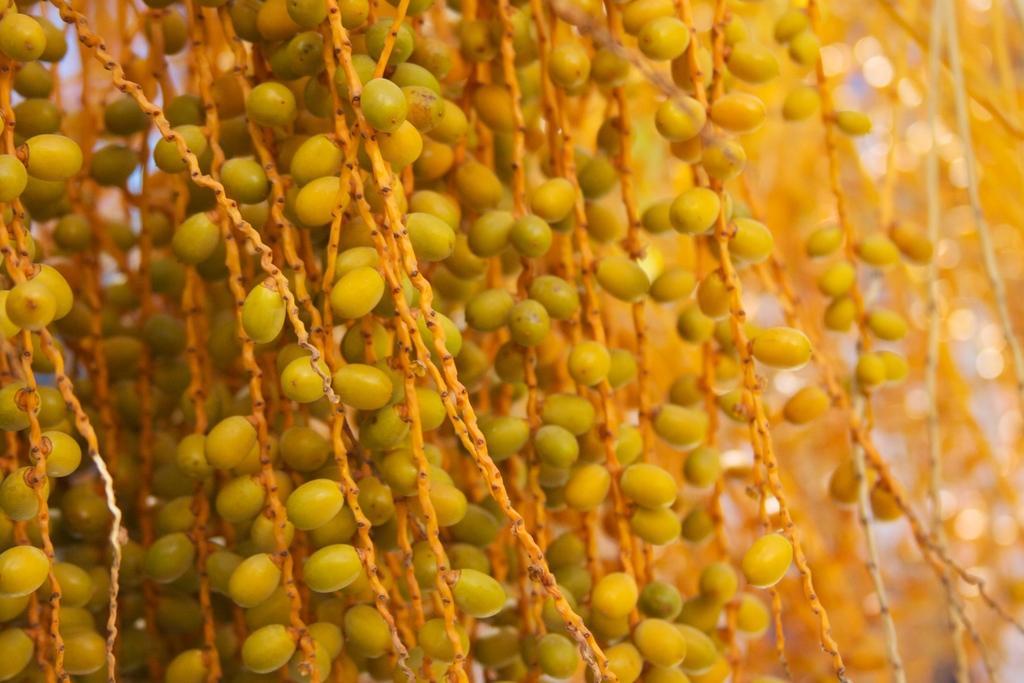Please provide a concise description of this image. In this picture there are seeds in the image. 